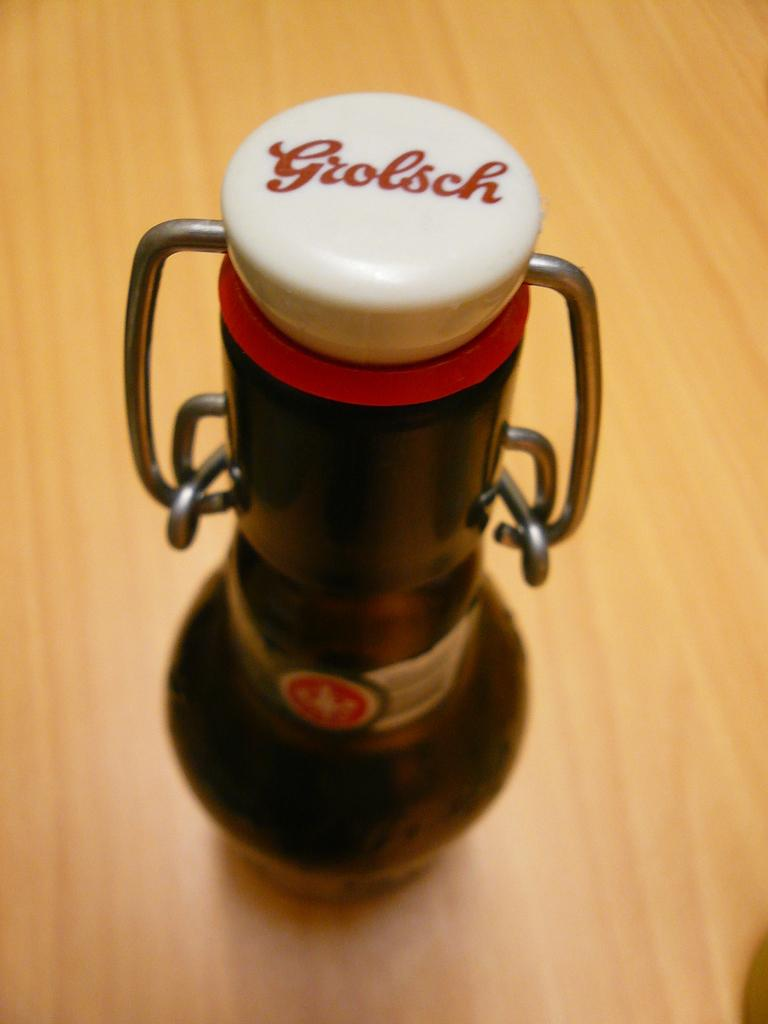Provide a one-sentence caption for the provided image. A Grolsch device is displayed on wooden surface. 